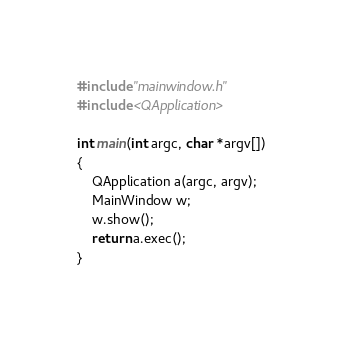Convert code to text. <code><loc_0><loc_0><loc_500><loc_500><_C++_>#include "mainwindow.h"
#include <QApplication>

int main(int argc, char *argv[])
{
    QApplication a(argc, argv);
    MainWindow w;    
    w.show();
    return a.exec();
}
</code> 